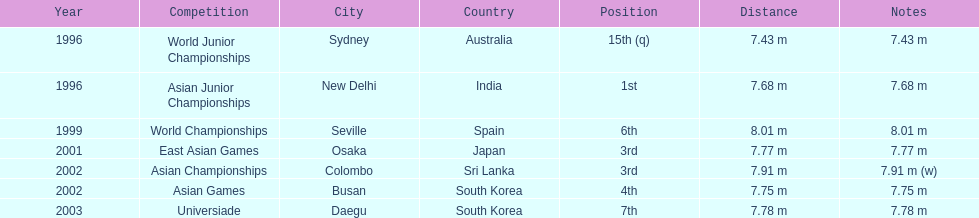What jumps did huang le make in 2002? 7.91 m (w), 7.75 m. Which jump was the longest? 7.91 m (w). 